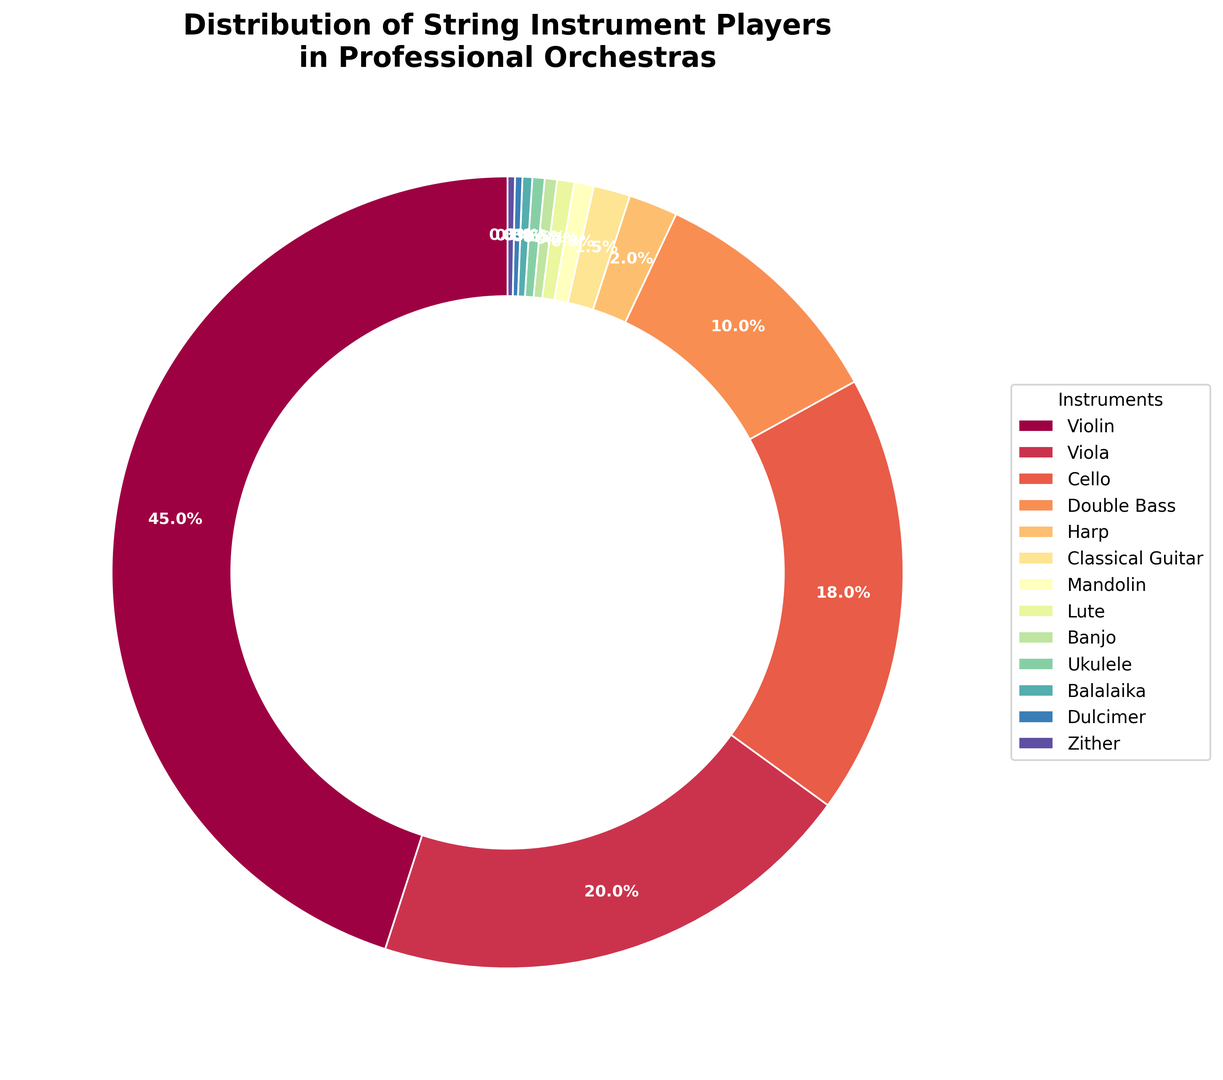What percentage of professional orchestra players play the violin? According to the chart, 45% of professional orchestra players play the violin.
Answer: 45% What is the difference in percentage between violinists and violists in professional orchestras? The percentage of violinists is 45% and the percentage of violists is 20%. The difference is 45% - 20% = 25%.
Answer: 25% How many times more violinists are there compared to harpists in professional orchestras? According to the chart, there are 45% violinists and 2% harpists. To find how many times more violinists there are, divide the percentage of violinists by the percentage of harpists: 45 / 2 = 22.5 times.
Answer: 22.5 times Which instrument has the smallest representation in professional orchestras? According to the chart, the instrument with the smallest representation is the Dulcimer and Zither, each with 0.3%.
Answer: Dulcimer, Zither Which two instruments together make up approximately 10% of professional orchestra players? According to the chart, the Double Bass makes up 10% on its own.
Answer: Double Bass Which section of the ring chart has the highest visual prominence? The largest wedge in the ring chart, which represents the instrument with the highest percentage, is the Violin section.
Answer: Violin What would be the combined percentage of string instruments other than Violin, Viola, and Cello? The Violin, Viola, and Cello together make up 45% + 20% + 18% = 83%. Therefore, the combined percentage of the other instruments would be 100% - 83% = 17%.
Answer: 17% Which is more common in professional orchestras, the Harp or the Classical Guitar? According to the chart, the Harp makes up 2% and the Classical Guitar makes up 1.5%. Therefore, the Harp is more common.
Answer: Harp Are there more viola players or cello players in professional orchestras? According to the chart, 20% of orchestra players are violists and 18% are cellists. So, there are more viola players.
Answer: Viola players If the ring chart was split into two halves, with one half representing Violinists and the other half representing all other instruments, which half would have a higher percentage? Violinists account for 45% of the chart. All other instruments combined account for 100% - 45% = 55%. Therefore, the other half representing all other instruments would have a higher percentage.
Answer: Other instruments 